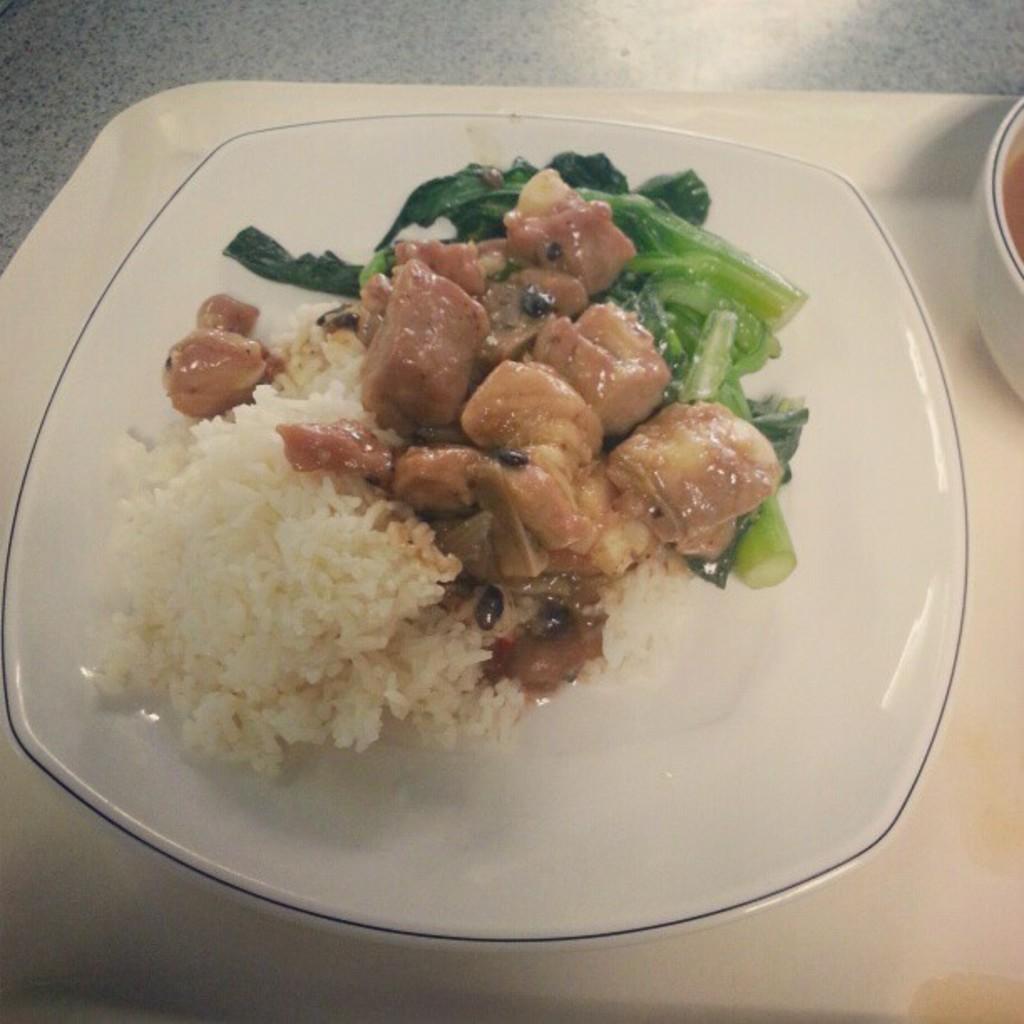Can you describe this image briefly? The picture consists of a plate, in the plate there are rice and other food items. On the right there is a bowl, they are placed in a tray. The tray is on the table. 